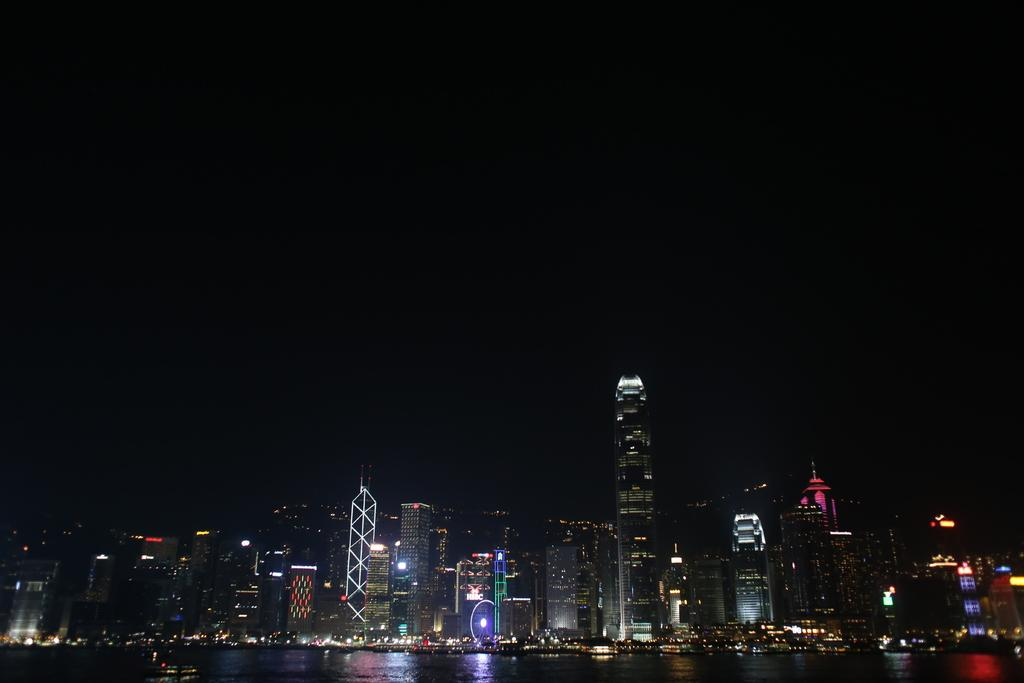What is visible in the image? Water is visible in the image. What can be seen in the distance in the image? There are buildings and lights in the background of the image. How would you describe the lighting conditions in the image? The background appears to be dark. What type of drug can be seen in the image? There is no drug present in the image. How many bees are visible in the image? There are no bees present in the image. 